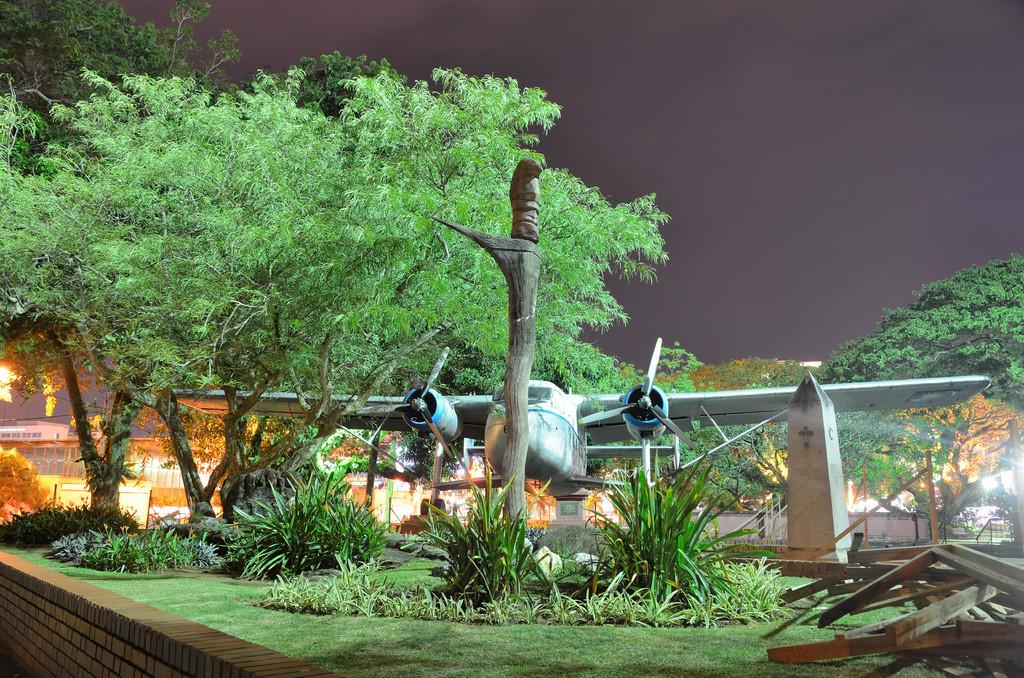What is the main subject of the picture? The main subject of the picture is a plane. What can be seen in front of the plane? There are wooden objects in front of the plane. What is visible in the background of the picture? There are trees in the background of the picture. How many sheep are visible in the picture? There are no sheep present in the picture; it features a plane and wooden objects in front of it. What type of bird can be seen perched on the wing of the plane? There is no bird visible on the plane in the picture. 